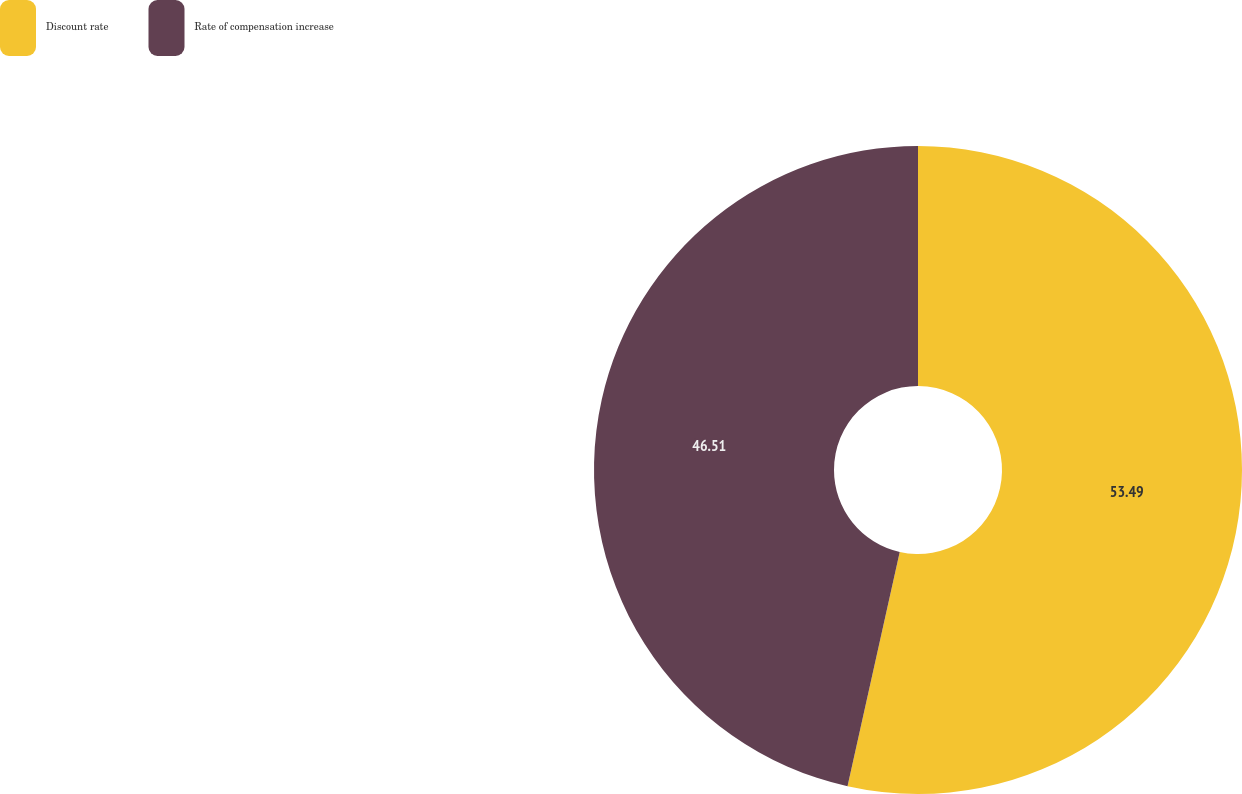Convert chart to OTSL. <chart><loc_0><loc_0><loc_500><loc_500><pie_chart><fcel>Discount rate<fcel>Rate of compensation increase<nl><fcel>53.49%<fcel>46.51%<nl></chart> 